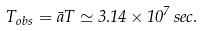Convert formula to latex. <formula><loc_0><loc_0><loc_500><loc_500>T _ { o b s } = \bar { a } T \simeq 3 . 1 4 \times 1 0 ^ { 7 } \, s e c .</formula> 